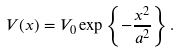Convert formula to latex. <formula><loc_0><loc_0><loc_500><loc_500>V ( x ) = V _ { 0 } \exp \left \{ - \frac { x ^ { 2 } } { a ^ { 2 } } \right \} .</formula> 